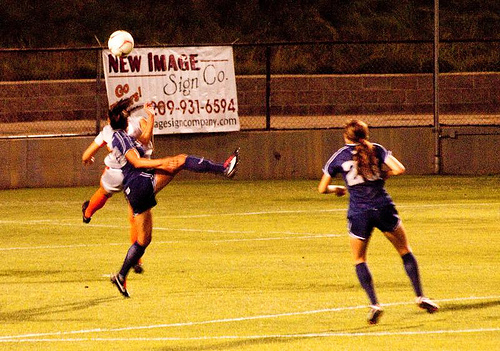<image>
Is the sign on the wall? Yes. Looking at the image, I can see the sign is positioned on top of the wall, with the wall providing support. Is the purple player on the white player? No. The purple player is not positioned on the white player. They may be near each other, but the purple player is not supported by or resting on top of the white player. Where is the ball in relation to the person? Is it above the person? No. The ball is not positioned above the person. The vertical arrangement shows a different relationship. 